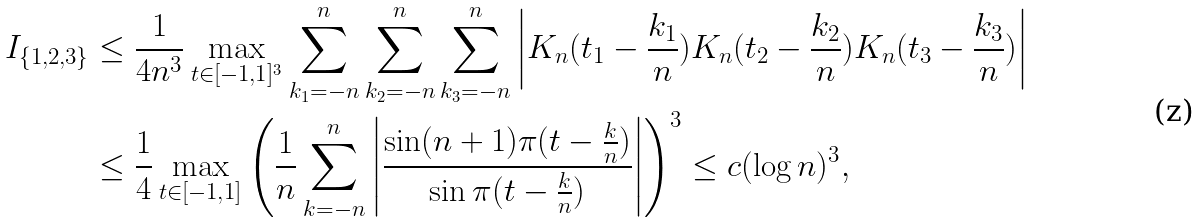Convert formula to latex. <formula><loc_0><loc_0><loc_500><loc_500>I _ { \{ 1 , 2 , 3 \} } & \leq \frac { 1 } { 4 n ^ { 3 } } \max _ { t \in { [ - 1 , 1 ] ^ { 3 } } } \sum _ { k _ { 1 } = - n } ^ { n } \sum _ { k _ { 2 } = - n } ^ { n } \sum _ { k _ { 3 } = - n } ^ { n } \left | K _ { n } ( t _ { 1 } - \frac { k _ { 1 } } { n } ) K _ { n } ( t _ { 2 } - \frac { k _ { 2 } } { n } ) K _ { n } ( t _ { 3 } - \frac { k _ { 3 } } { n } ) \right | \\ & \leq \frac { 1 } { 4 } \max _ { t \in { [ - 1 , 1 ] } } \left ( \frac { 1 } { n } \sum _ { k = - n } ^ { n } \left | \frac { \sin ( n + 1 ) \pi ( t - \frac { k } { n } ) } { \sin \pi ( t - \frac { k } { n } ) } \right | \right ) ^ { 3 } \leq c ( \log n ) ^ { 3 } ,</formula> 